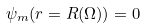Convert formula to latex. <formula><loc_0><loc_0><loc_500><loc_500>\psi _ { m } ( r = R ( \Omega ) ) = 0</formula> 